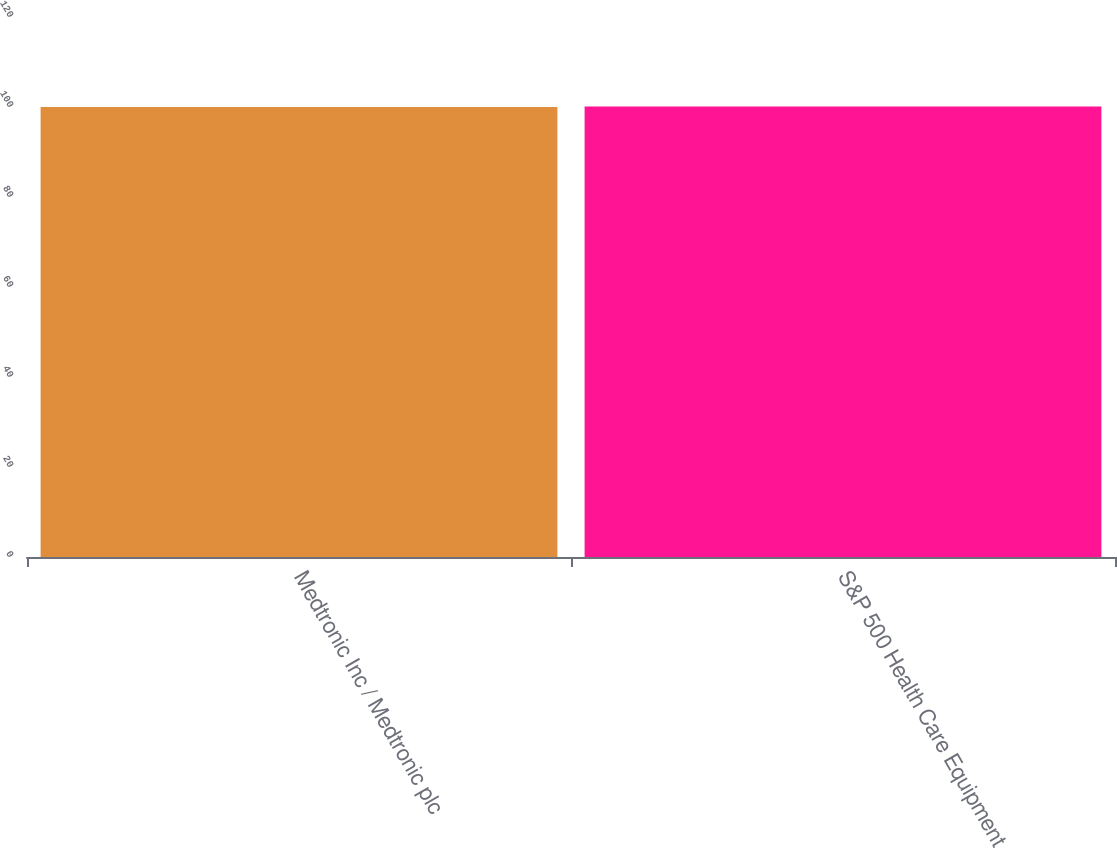Convert chart. <chart><loc_0><loc_0><loc_500><loc_500><bar_chart><fcel>Medtronic Inc / Medtronic plc<fcel>S&P 500 Health Care Equipment<nl><fcel>100<fcel>100.1<nl></chart> 